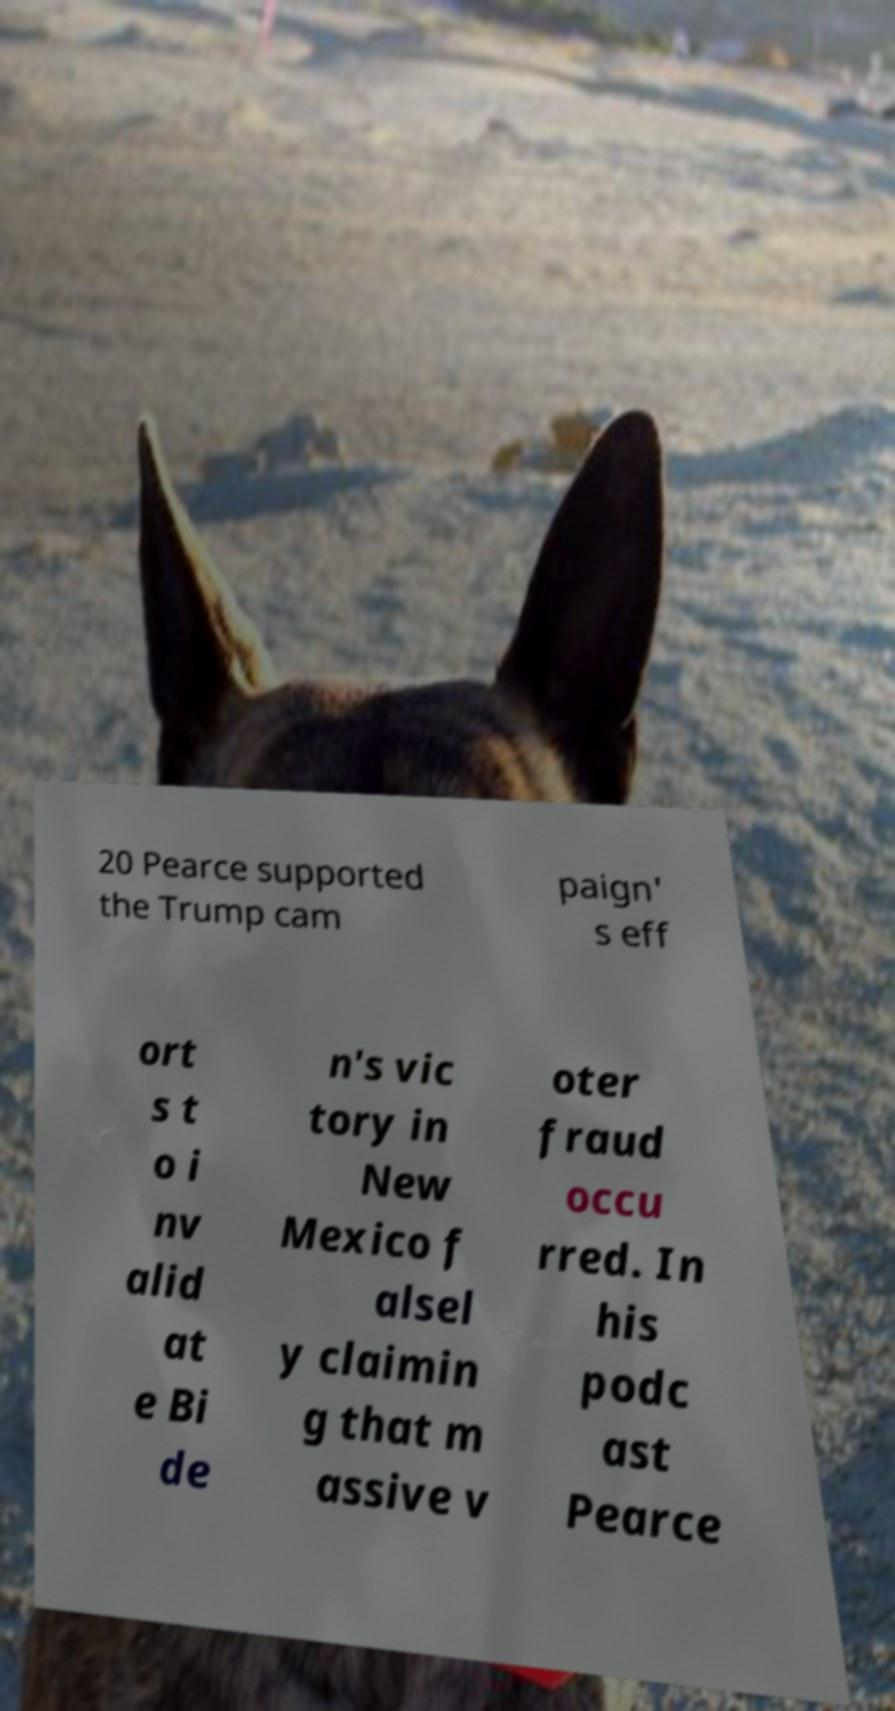For documentation purposes, I need the text within this image transcribed. Could you provide that? 20 Pearce supported the Trump cam paign' s eff ort s t o i nv alid at e Bi de n's vic tory in New Mexico f alsel y claimin g that m assive v oter fraud occu rred. In his podc ast Pearce 